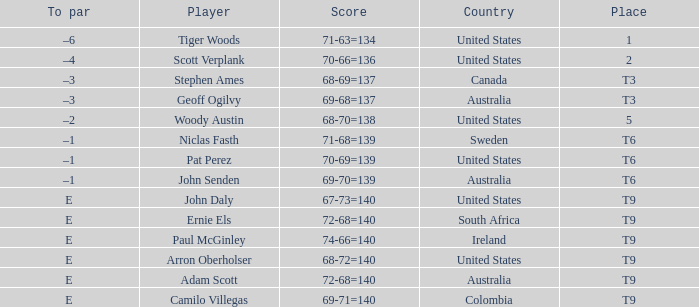Which player has a to par of e and a score of 67-73=140? John Daly. 